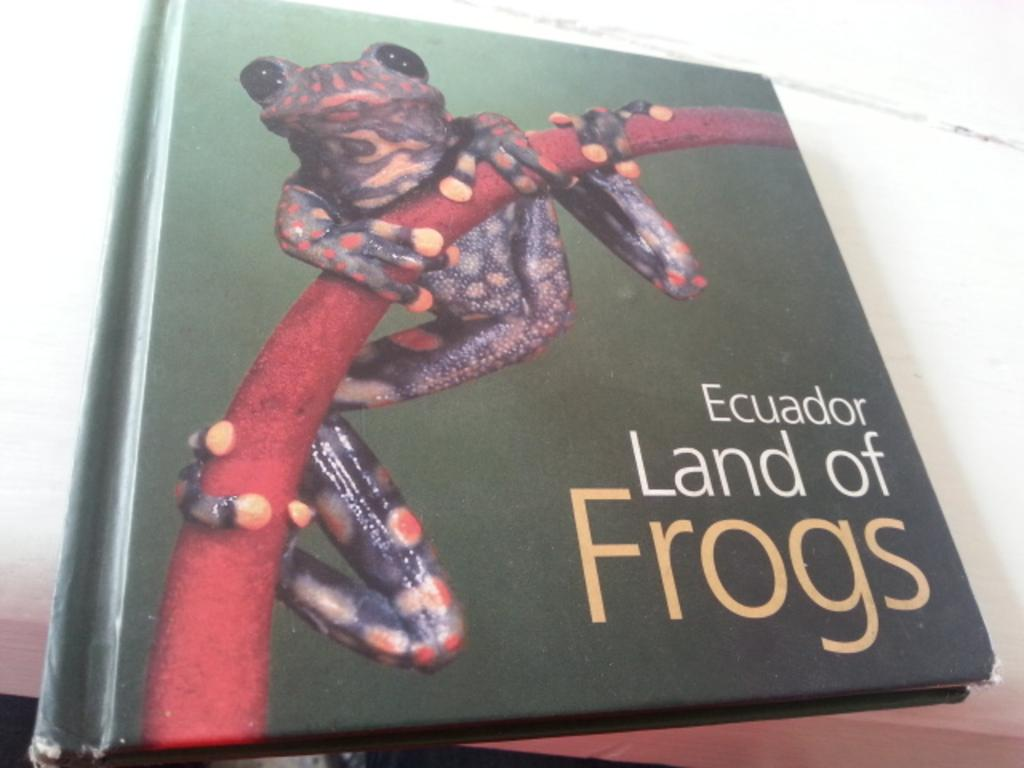Provide a one-sentence caption for the provided image. The book is about the frogs in Ecuador. 